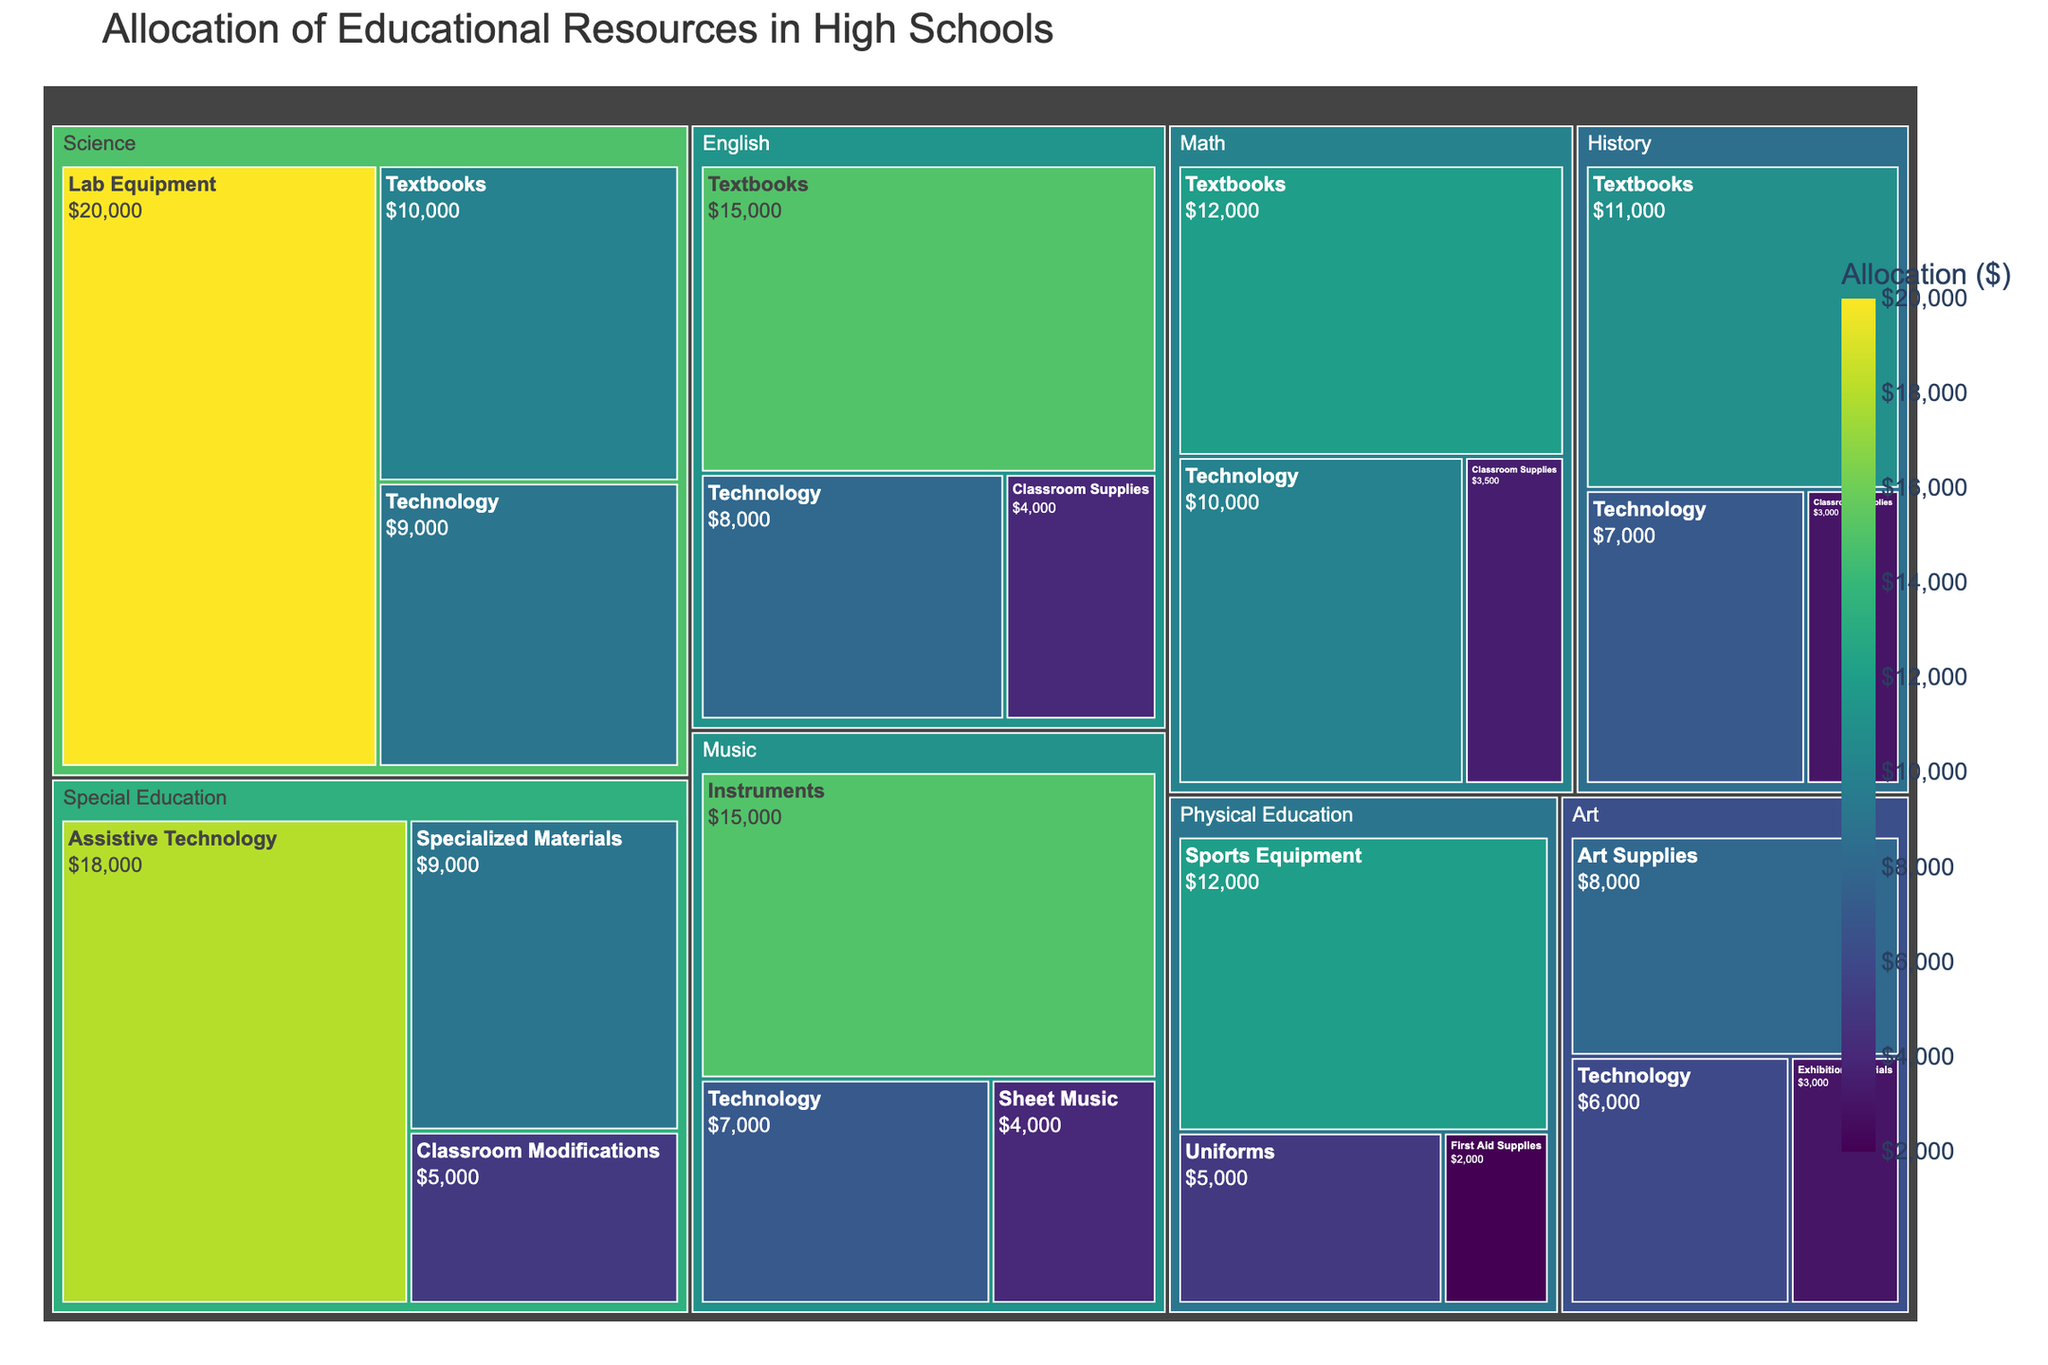Which department has the highest allocation for technology? Look for the largest block within each department labeled 'Technology' and compare them.
Answer: Math What is the total allocation for the English department? Sum the allocations for all categories within the English department: $15,000 (Textbooks) + $8,000 (Technology) + $4,000 (Classroom Supplies).
Answer: $27,000 Which two departments received the least overall funding? Identify the smallest total allocations by summing the values of all categories within each department and compare them.
Answer: Art and Physical Education How does the allocation for lab equipment in Science compare to the allocation for instruments in Music? Compare the values: $20,000 (Lab Equipment) vs. $15,000 (Instruments).
Answer: Lab Equipment in Science is higher Which category within the Math department has the lowest allocation? Identify the smallest block within the Math department.
Answer: Classroom Supplies What is the total allocation for specialized materials and classroom modifications in Special Education? Sum the values for Specialized Materials and Classroom Modifications: $9,000 + $5,000.
Answer: $14,000 Which department has the most varied allocation categories? Count the number of different categories within each department and identify the one with the most.
Answer: Special Education What is the difference in allocation between textbooks in Science and History departments? Find the allocations for Textbooks in each department and calculate the difference: $10,000 (Science) - $11,000 (History).
Answer: $1,000 less in Science How does the allocation for sports equipment in Physical Education compare to the total allocation in the Art department? Compare the value of Sports Equipment ($12,000) with the sum of all allocations in Art: $8,000 + $6,000 + $3,000 = $17,000.
Answer: Arts' allocation is higher 